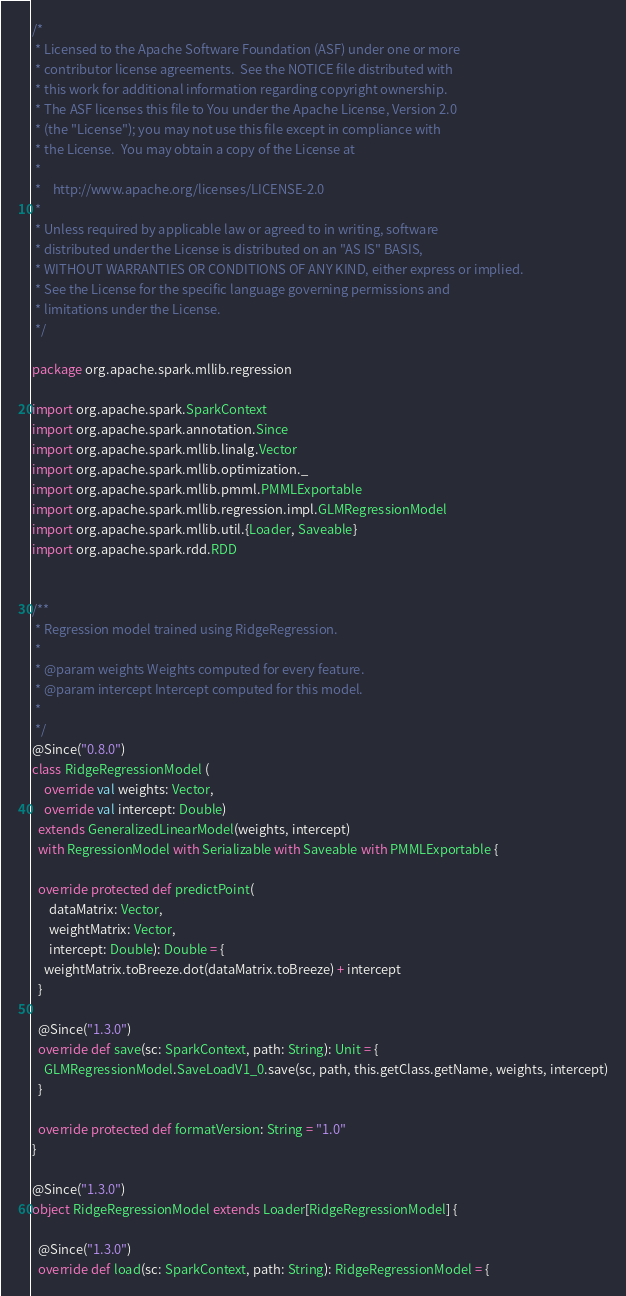<code> <loc_0><loc_0><loc_500><loc_500><_Scala_>/*
 * Licensed to the Apache Software Foundation (ASF) under one or more
 * contributor license agreements.  See the NOTICE file distributed with
 * this work for additional information regarding copyright ownership.
 * The ASF licenses this file to You under the Apache License, Version 2.0
 * (the "License"); you may not use this file except in compliance with
 * the License.  You may obtain a copy of the License at
 *
 *    http://www.apache.org/licenses/LICENSE-2.0
 *
 * Unless required by applicable law or agreed to in writing, software
 * distributed under the License is distributed on an "AS IS" BASIS,
 * WITHOUT WARRANTIES OR CONDITIONS OF ANY KIND, either express or implied.
 * See the License for the specific language governing permissions and
 * limitations under the License.
 */

package org.apache.spark.mllib.regression

import org.apache.spark.SparkContext
import org.apache.spark.annotation.Since
import org.apache.spark.mllib.linalg.Vector
import org.apache.spark.mllib.optimization._
import org.apache.spark.mllib.pmml.PMMLExportable
import org.apache.spark.mllib.regression.impl.GLMRegressionModel
import org.apache.spark.mllib.util.{Loader, Saveable}
import org.apache.spark.rdd.RDD


/**
 * Regression model trained using RidgeRegression.
 *
 * @param weights Weights computed for every feature.
 * @param intercept Intercept computed for this model.
 *
 */
@Since("0.8.0")
class RidgeRegressionModel (
    override val weights: Vector,
    override val intercept: Double)
  extends GeneralizedLinearModel(weights, intercept)
  with RegressionModel with Serializable with Saveable with PMMLExportable {

  override protected def predictPoint(
      dataMatrix: Vector,
      weightMatrix: Vector,
      intercept: Double): Double = {
    weightMatrix.toBreeze.dot(dataMatrix.toBreeze) + intercept
  }

  @Since("1.3.0")
  override def save(sc: SparkContext, path: String): Unit = {
    GLMRegressionModel.SaveLoadV1_0.save(sc, path, this.getClass.getName, weights, intercept)
  }

  override protected def formatVersion: String = "1.0"
}

@Since("1.3.0")
object RidgeRegressionModel extends Loader[RidgeRegressionModel] {

  @Since("1.3.0")
  override def load(sc: SparkContext, path: String): RidgeRegressionModel = {</code> 